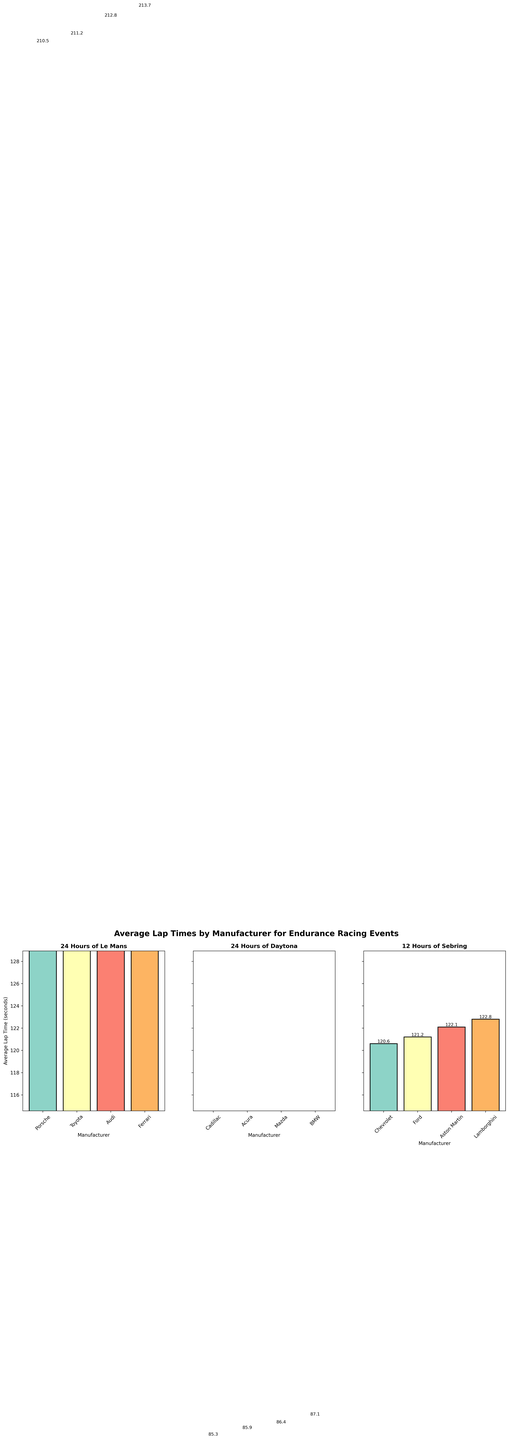How many events are represented in the figure? The figure displays subplots for each event, and each subplot has a title indicating the event. By counting the number of subplots, you can determine the number of events. There are three events: "24 Hours of Le Mans," "24 Hours of Daytona," and "12 Hours of Sebring."
Answer: 3 Which manufacturer has the slowest average lap time at the 12 Hours of Sebring? By looking at the subplot for the "12 Hours of Sebring," identify the manufacturer with the highest bar, as taller bars indicate longer lap times. Lamborghini has the highest average lap time in this subplot.
Answer: Lamborghini What is the range of average lap times for the 24 Hours of Le Mans event? The range is calculated by subtracting the smallest lap time from the largest lap time in the "24 Hours of Le Mans" subplot. The manufacturers have lap times of 210.5, 211.2, 212.8, and 213.7 seconds, so the range is 213.7 - 210.5.
Answer: 3.2 seconds Compare the average lap times between Toyota at the 24 Hours of Le Mans and Mazda at the 24 Hours of Daytona. Which is faster? Locate Toyota's bar in the "24 Hours of Le Mans" subplot and Mazda's bar in the "24 Hours of Daytona" subplot. Toyota has a lap time of 211.2 seconds, whereas Mazda has a lap time of 86.4 seconds. Since these two events have different scales, we need to compare the raw lap times: 86.4 seconds is faster.
Answer: Mazda What is the difference in the average lap times between Porsche and Audi at the 24 Hours of Le Mans? In the "24 Hours of Le Mans" subplot, the average lap times for Porsche and Audi are 210.5 seconds and 212.8 seconds, respectively. Subtract the smaller value from the larger one: 212.8 - 210.5.
Answer: 2.3 seconds Which event shows the smallest variation in average lap times among its manufacturers? Examine the range of lap times in each subplot by identifying the difference between the highest and lowest lap times in each event. "24 Hours of Daytona" exhibits the smallest variation, with lap times ranging from 85.3 to 87.1 seconds, a difference of only 1.8 seconds.
Answer: 24 Hours of Daytona How does the lap time of Ford at the 12 Hours of Sebring compare to the lap time of Acura at the 24 Hours of Daytona? Find Ford's lap time in the "12 Hours of Sebring" subplot, which is 121.2 seconds, and Acura's lap time in the "24 Hours of Daytona" subplot, which is 85.9 seconds. Ford's lap time is considerably higher.
Answer: Ford is slower At which event does the manufacturer with the shortest average lap time compete? Identify the shortest bar (indicating the shortest average lap time) across all subplots. Porsche at the "24 Hours of Le Mans" has the shortest average lap time of 210.5 seconds.
Answer: 24 Hours of Le Mans What is the average lap time of all manufacturers at the 24 Hours of Daytona? Sum the average lap times of all manufacturers in the "24 Hours of Daytona" subplot and divide by the number of manufacturers. The lap times are 85.3, 85.9, 86.4, and 87.1 seconds. The sum is 344.7, and there are 4 manufacturers, so the average is 344.7 / 4.
Answer: 86.2 seconds 